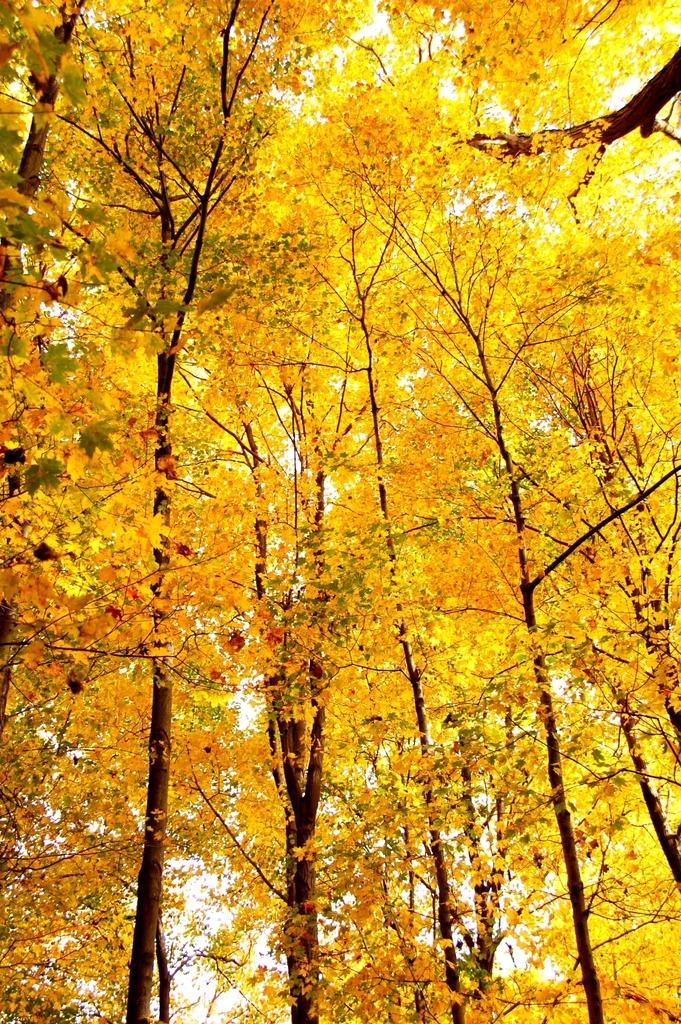What type of vegetation can be seen in the image? There are trees in the image. What is the color of the leaves on the trees? The leaves on the trees are yellow in color. What type of alarm can be heard going off in the image? There is no alarm present in the image, as it is a still image and cannot produce sound. 